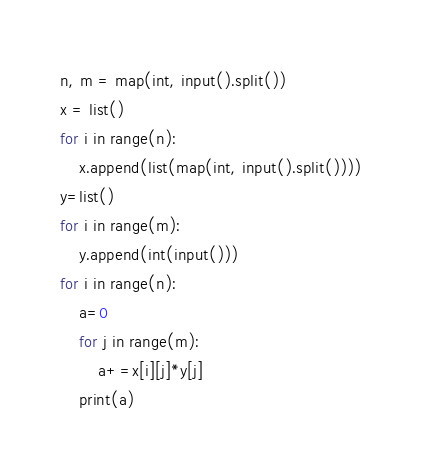Convert code to text. <code><loc_0><loc_0><loc_500><loc_500><_Python_>n, m = map(int, input().split())
x = list()
for i in range(n):
    x.append(list(map(int, input().split())))
y=list()
for i in range(m):
    y.append(int(input()))
for i in range(n):
    a=0
    for j in range(m):
        a+=x[i][j]*y[j]
    print(a)
</code> 